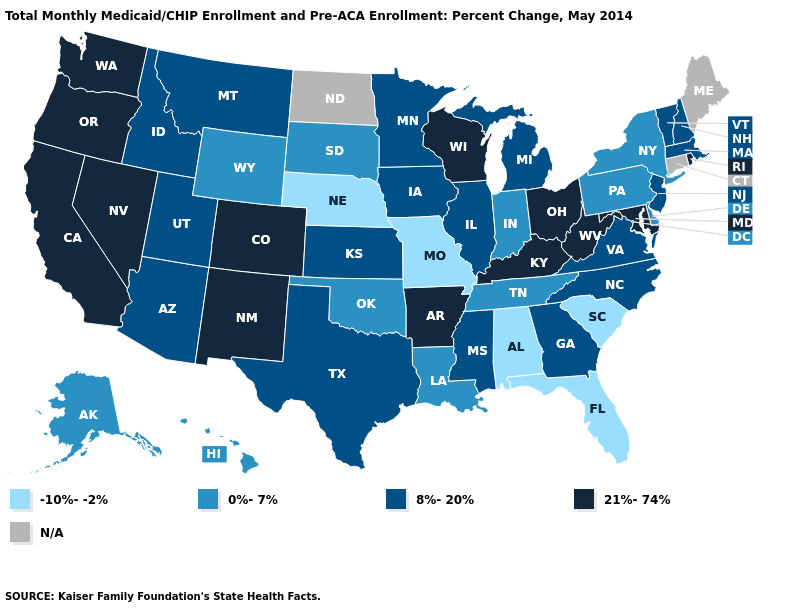What is the value of Illinois?
Write a very short answer. 8%-20%. Does the map have missing data?
Concise answer only. Yes. What is the value of Utah?
Write a very short answer. 8%-20%. Among the states that border Connecticut , which have the lowest value?
Answer briefly. New York. Among the states that border Texas , which have the highest value?
Quick response, please. Arkansas, New Mexico. Is the legend a continuous bar?
Write a very short answer. No. Name the states that have a value in the range 0%-7%?
Short answer required. Alaska, Delaware, Hawaii, Indiana, Louisiana, New York, Oklahoma, Pennsylvania, South Dakota, Tennessee, Wyoming. What is the highest value in the South ?
Short answer required. 21%-74%. What is the highest value in states that border Kentucky?
Short answer required. 21%-74%. Among the states that border Oklahoma , does Kansas have the lowest value?
Be succinct. No. Among the states that border Tennessee , which have the lowest value?
Give a very brief answer. Alabama, Missouri. What is the value of Wyoming?
Write a very short answer. 0%-7%. 